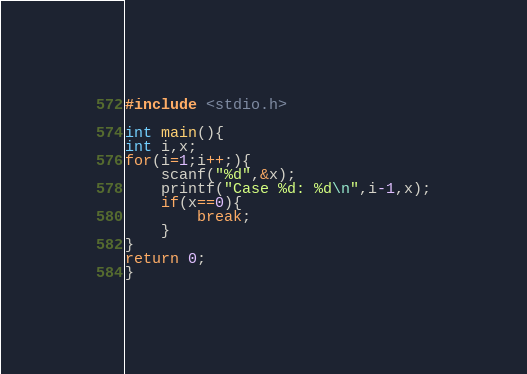Convert code to text. <code><loc_0><loc_0><loc_500><loc_500><_C_>#include <stdio.h>

int main(){
int i,x;
for(i=1;i++;){
	scanf("%d",&x);
	printf("Case %d: %d\n",i-1,x);
	if(x==0){
		break;
	}
}
return 0;
}</code> 